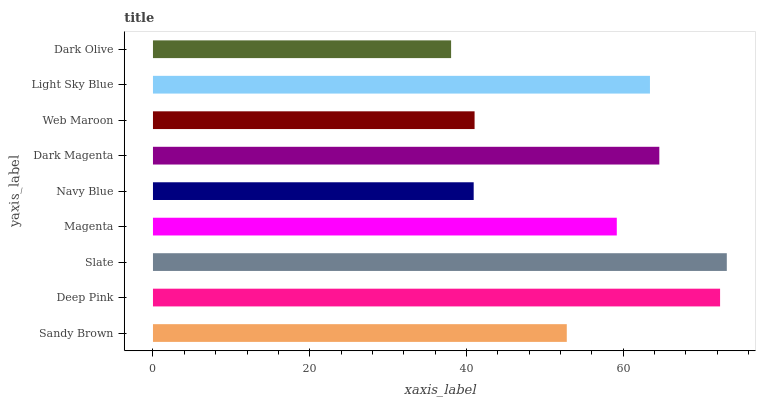Is Dark Olive the minimum?
Answer yes or no. Yes. Is Slate the maximum?
Answer yes or no. Yes. Is Deep Pink the minimum?
Answer yes or no. No. Is Deep Pink the maximum?
Answer yes or no. No. Is Deep Pink greater than Sandy Brown?
Answer yes or no. Yes. Is Sandy Brown less than Deep Pink?
Answer yes or no. Yes. Is Sandy Brown greater than Deep Pink?
Answer yes or no. No. Is Deep Pink less than Sandy Brown?
Answer yes or no. No. Is Magenta the high median?
Answer yes or no. Yes. Is Magenta the low median?
Answer yes or no. Yes. Is Slate the high median?
Answer yes or no. No. Is Dark Magenta the low median?
Answer yes or no. No. 